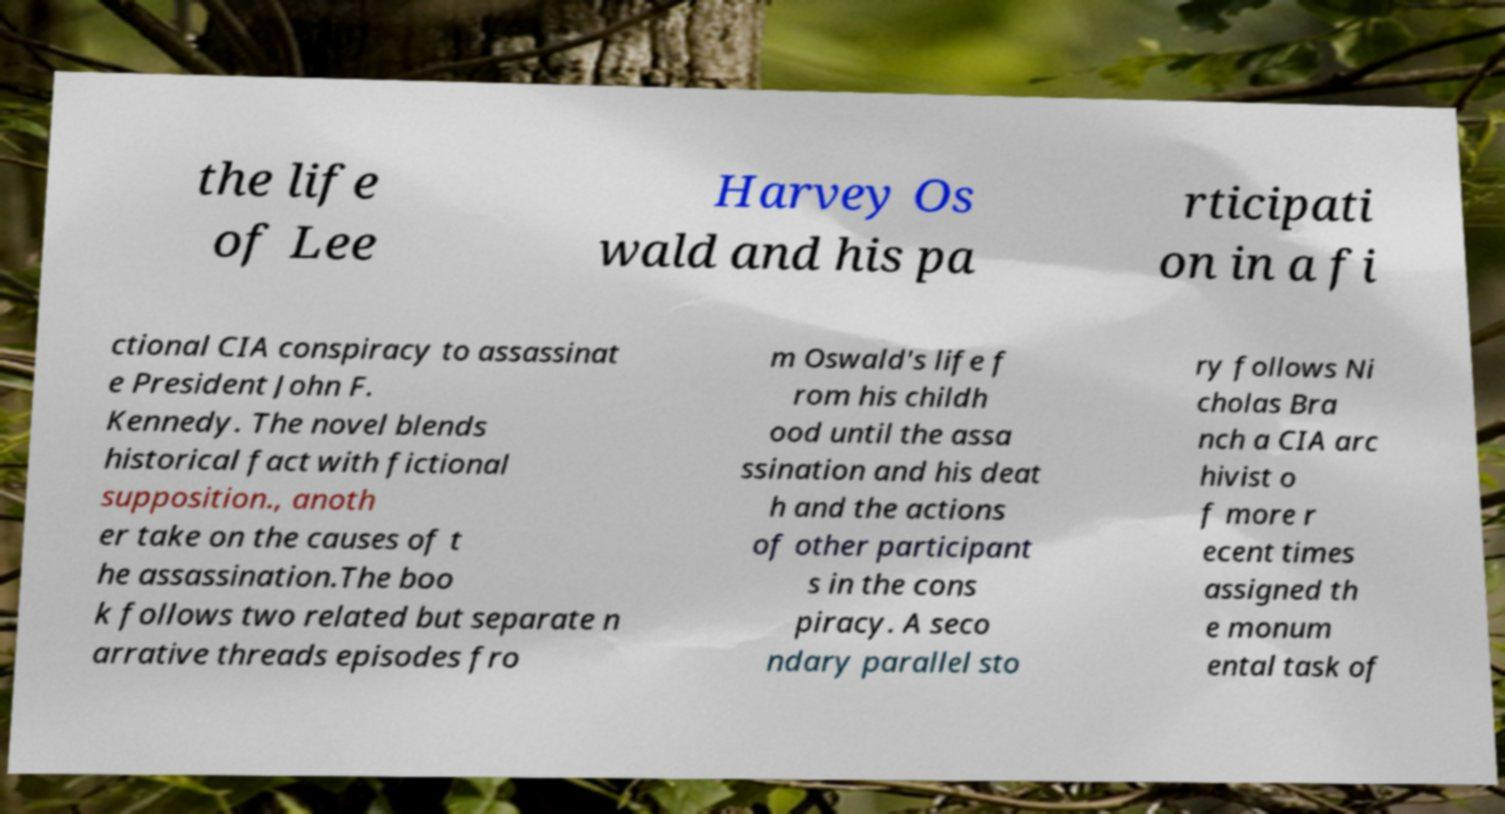Could you assist in decoding the text presented in this image and type it out clearly? the life of Lee Harvey Os wald and his pa rticipati on in a fi ctional CIA conspiracy to assassinat e President John F. Kennedy. The novel blends historical fact with fictional supposition., anoth er take on the causes of t he assassination.The boo k follows two related but separate n arrative threads episodes fro m Oswald's life f rom his childh ood until the assa ssination and his deat h and the actions of other participant s in the cons piracy. A seco ndary parallel sto ry follows Ni cholas Bra nch a CIA arc hivist o f more r ecent times assigned th e monum ental task of 